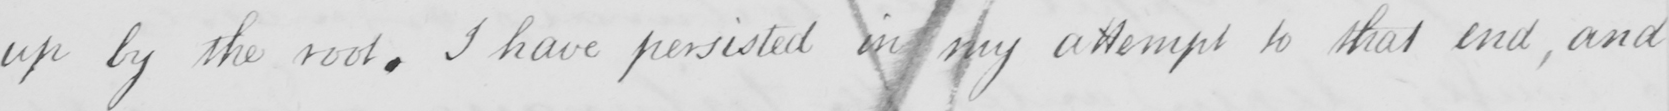Transcribe the text shown in this historical manuscript line. up by the root. I have persisted in my attempt to that end, and 